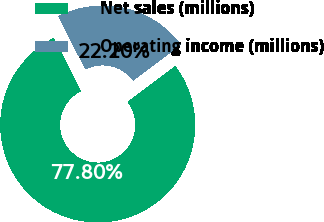Convert chart to OTSL. <chart><loc_0><loc_0><loc_500><loc_500><pie_chart><fcel>Net sales (millions)<fcel>Operating income (millions)<nl><fcel>77.8%<fcel>22.2%<nl></chart> 